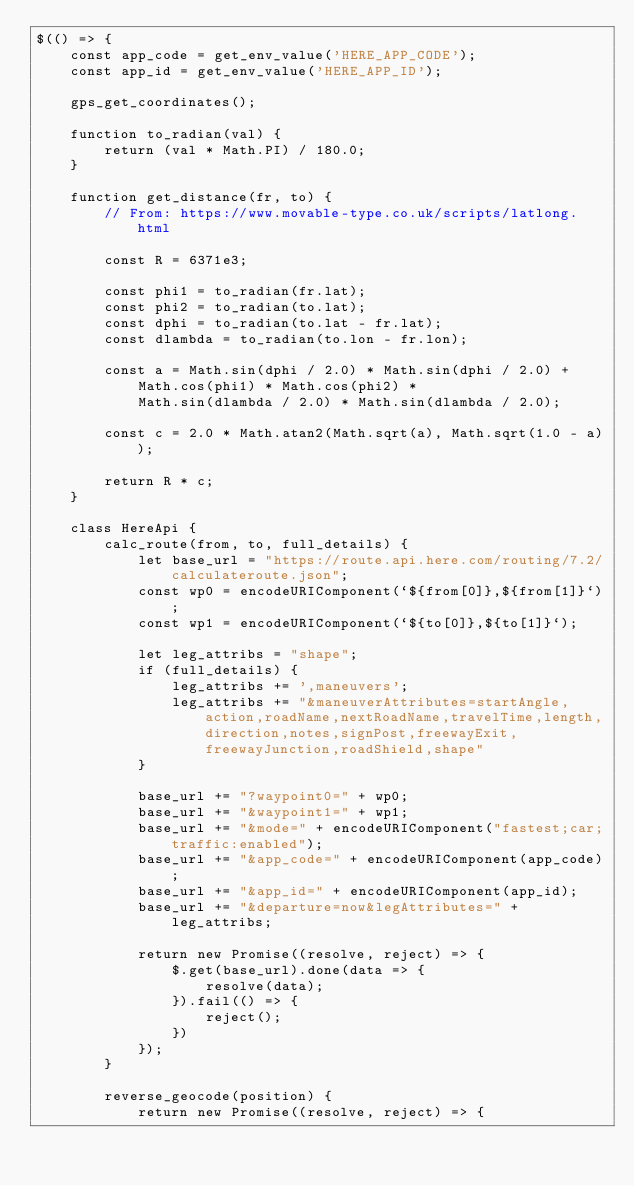<code> <loc_0><loc_0><loc_500><loc_500><_JavaScript_>$(() => {
    const app_code = get_env_value('HERE_APP_CODE');
    const app_id = get_env_value('HERE_APP_ID');

    gps_get_coordinates();

    function to_radian(val) {
        return (val * Math.PI) / 180.0;
    }

    function get_distance(fr, to) {
        // From: https://www.movable-type.co.uk/scripts/latlong.html

        const R = 6371e3;

        const phi1 = to_radian(fr.lat);
        const phi2 = to_radian(to.lat);
        const dphi = to_radian(to.lat - fr.lat);
        const dlambda = to_radian(to.lon - fr.lon);

        const a = Math.sin(dphi / 2.0) * Math.sin(dphi / 2.0) +
            Math.cos(phi1) * Math.cos(phi2) *
            Math.sin(dlambda / 2.0) * Math.sin(dlambda / 2.0);

        const c = 2.0 * Math.atan2(Math.sqrt(a), Math.sqrt(1.0 - a));

        return R * c;
    }

    class HereApi {
        calc_route(from, to, full_details) {
            let base_url = "https://route.api.here.com/routing/7.2/calculateroute.json";
            const wp0 = encodeURIComponent(`${from[0]},${from[1]}`);
            const wp1 = encodeURIComponent(`${to[0]},${to[1]}`);

            let leg_attribs = "shape";
            if (full_details) {
                leg_attribs += ',maneuvers';
                leg_attribs += "&maneuverAttributes=startAngle,action,roadName,nextRoadName,travelTime,length,direction,notes,signPost,freewayExit,freewayJunction,roadShield,shape"
            }

            base_url += "?waypoint0=" + wp0;
            base_url += "&waypoint1=" + wp1;
            base_url += "&mode=" + encodeURIComponent("fastest;car;traffic:enabled");
            base_url += "&app_code=" + encodeURIComponent(app_code);
            base_url += "&app_id=" + encodeURIComponent(app_id);
            base_url += "&departure=now&legAttributes=" + leg_attribs;

            return new Promise((resolve, reject) => {
                $.get(base_url).done(data => {
                    resolve(data);
                }).fail(() => {
                    reject();
                })
            });
        }

        reverse_geocode(position) {
            return new Promise((resolve, reject) => {</code> 